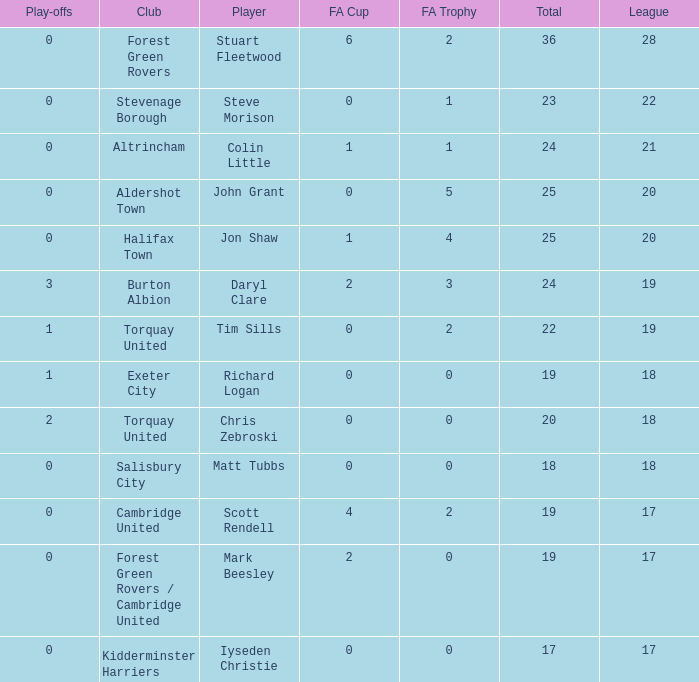What mean total had a league number of 18, Richard Logan as a player, and a play-offs number smaller than 1? None. 